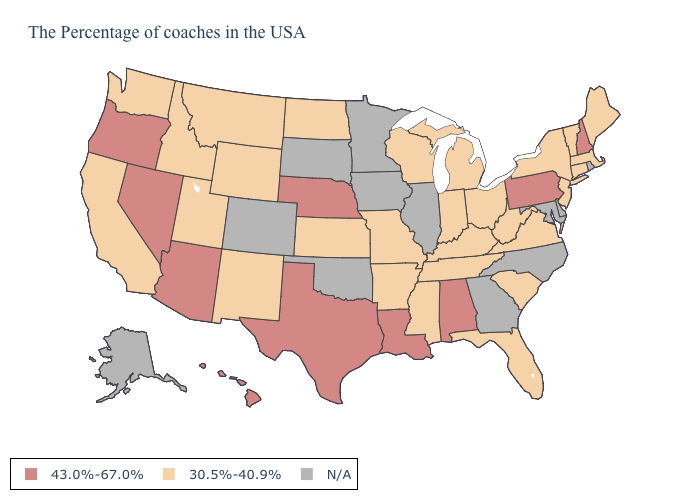Which states have the lowest value in the USA?
Write a very short answer. Maine, Massachusetts, Vermont, Connecticut, New York, New Jersey, Virginia, South Carolina, West Virginia, Ohio, Florida, Michigan, Kentucky, Indiana, Tennessee, Wisconsin, Mississippi, Missouri, Arkansas, Kansas, North Dakota, Wyoming, New Mexico, Utah, Montana, Idaho, California, Washington. Name the states that have a value in the range 30.5%-40.9%?
Give a very brief answer. Maine, Massachusetts, Vermont, Connecticut, New York, New Jersey, Virginia, South Carolina, West Virginia, Ohio, Florida, Michigan, Kentucky, Indiana, Tennessee, Wisconsin, Mississippi, Missouri, Arkansas, Kansas, North Dakota, Wyoming, New Mexico, Utah, Montana, Idaho, California, Washington. What is the value of Wisconsin?
Concise answer only. 30.5%-40.9%. What is the value of Louisiana?
Be succinct. 43.0%-67.0%. Among the states that border North Carolina , which have the highest value?
Concise answer only. Virginia, South Carolina, Tennessee. What is the value of Louisiana?
Short answer required. 43.0%-67.0%. What is the lowest value in states that border Vermont?
Short answer required. 30.5%-40.9%. How many symbols are there in the legend?
Concise answer only. 3. Name the states that have a value in the range N/A?
Quick response, please. Rhode Island, Delaware, Maryland, North Carolina, Georgia, Illinois, Minnesota, Iowa, Oklahoma, South Dakota, Colorado, Alaska. What is the value of Colorado?
Write a very short answer. N/A. Among the states that border Colorado , does New Mexico have the lowest value?
Short answer required. Yes. What is the value of California?
Write a very short answer. 30.5%-40.9%. What is the highest value in the USA?
Write a very short answer. 43.0%-67.0%. 